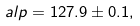Convert formula to latex. <formula><loc_0><loc_0><loc_500><loc_500>\ a l p = 1 2 7 . 9 \pm 0 . 1 ,</formula> 